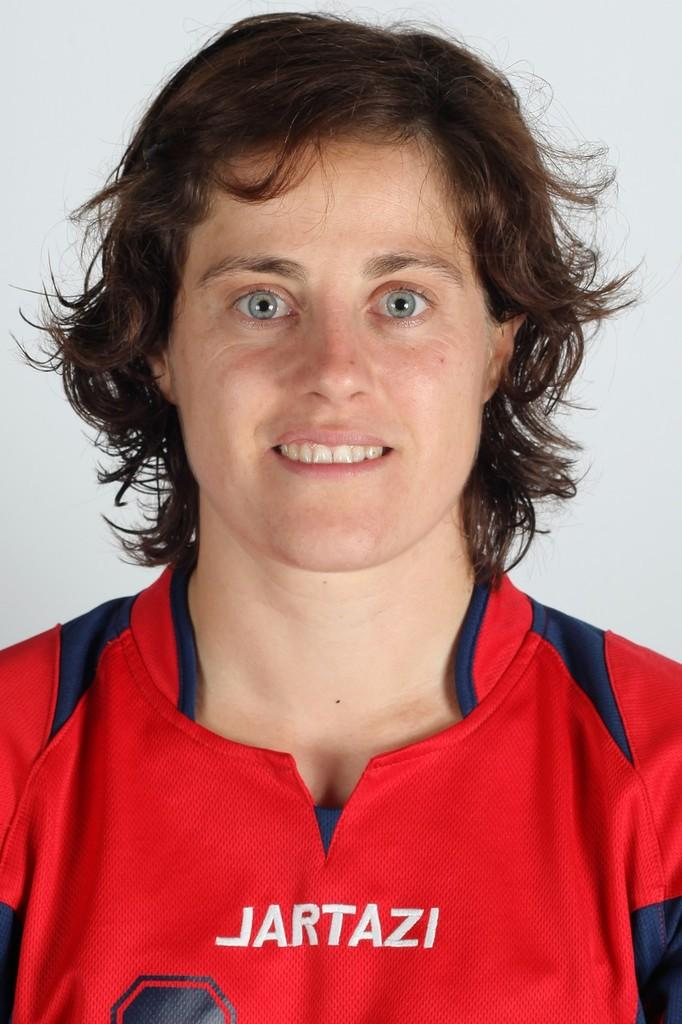What is present in the image? There is a person in the image. What is the person wearing? The person is wearing a red T-shirt. How many teeth can be seen in the image? There are no teeth visible in the image, as it features a person wearing a red T-shirt. How many boys are present in the image? The image only shows one person, so it is not possible to determine the number of boys. 